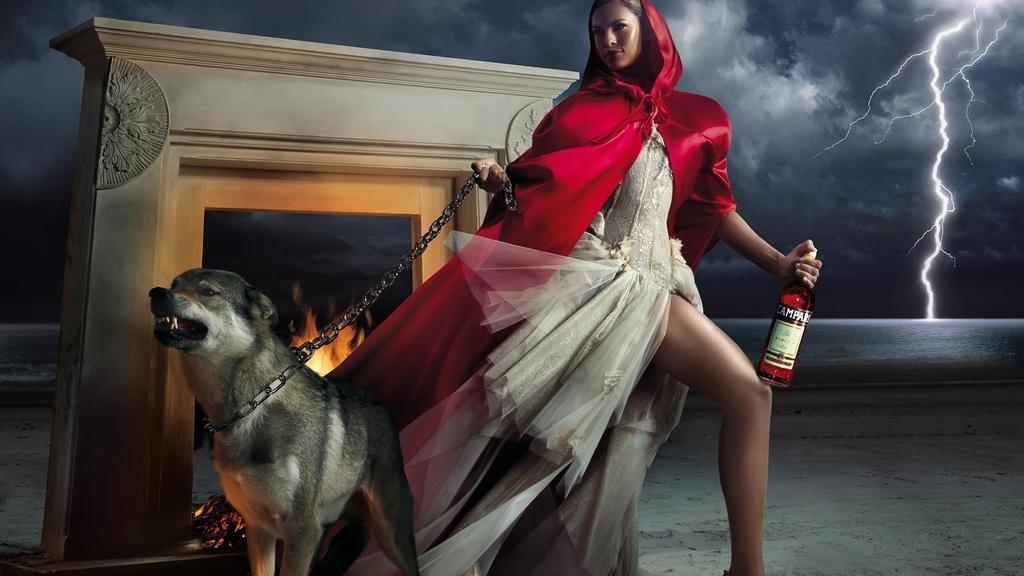How would you summarize this image in a sentence or two? This is an animated picture. On the background we can see sky with clouds and thunders. Here we can see a woman holding a bottle in her hand and on the other hand she is holding a chain of a dog. Here we can see a fire. 